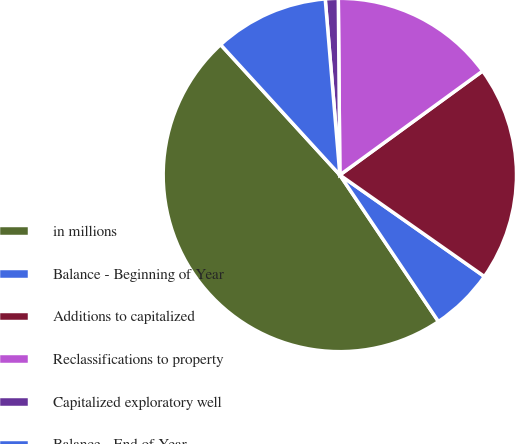<chart> <loc_0><loc_0><loc_500><loc_500><pie_chart><fcel>in millions<fcel>Balance - Beginning of Year<fcel>Additions to capitalized<fcel>Reclassifications to property<fcel>Capitalized exploratory well<fcel>Balance - End of Year<nl><fcel>47.63%<fcel>5.83%<fcel>19.76%<fcel>15.12%<fcel>1.18%<fcel>10.47%<nl></chart> 